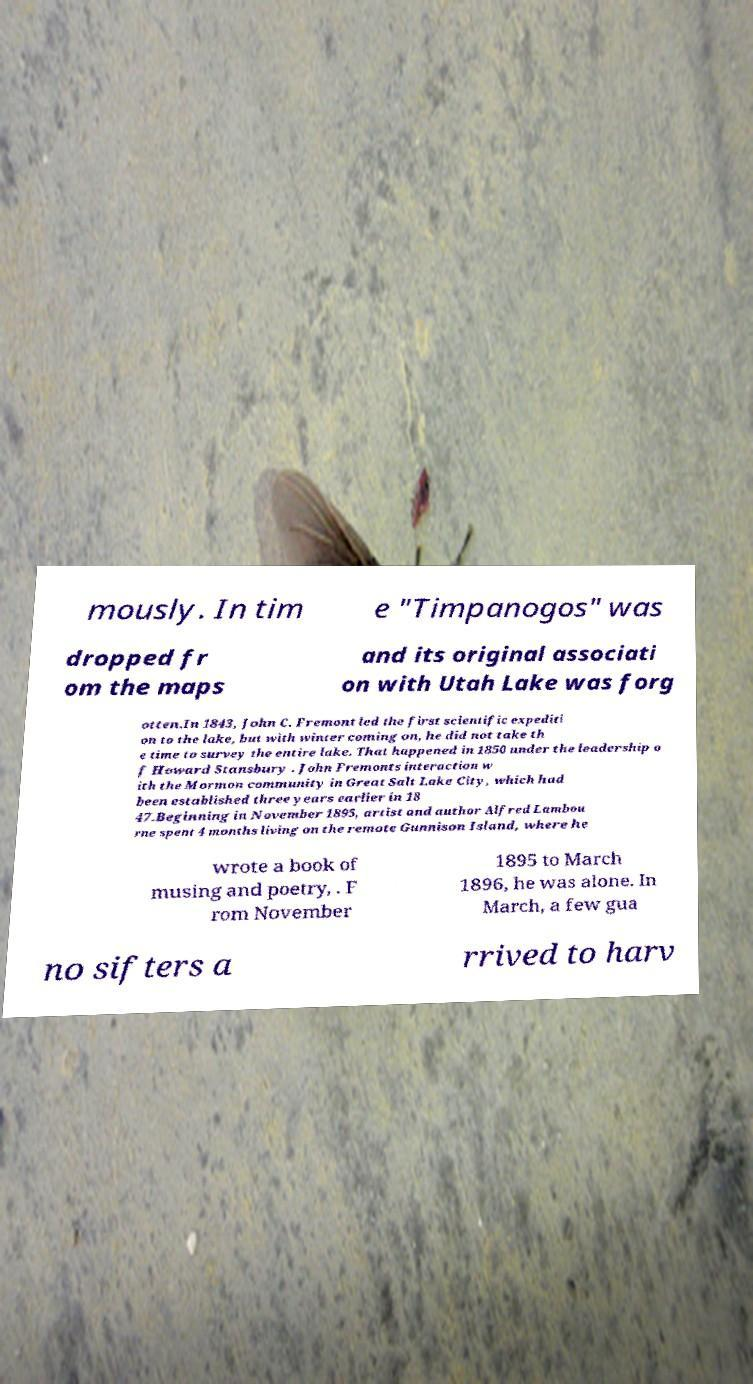Could you assist in decoding the text presented in this image and type it out clearly? mously. In tim e "Timpanogos" was dropped fr om the maps and its original associati on with Utah Lake was forg otten.In 1843, John C. Fremont led the first scientific expediti on to the lake, but with winter coming on, he did not take th e time to survey the entire lake. That happened in 1850 under the leadership o f Howard Stansbury . John Fremonts interaction w ith the Mormon community in Great Salt Lake City, which had been established three years earlier in 18 47.Beginning in November 1895, artist and author Alfred Lambou rne spent 4 months living on the remote Gunnison Island, where he wrote a book of musing and poetry, . F rom November 1895 to March 1896, he was alone. In March, a few gua no sifters a rrived to harv 